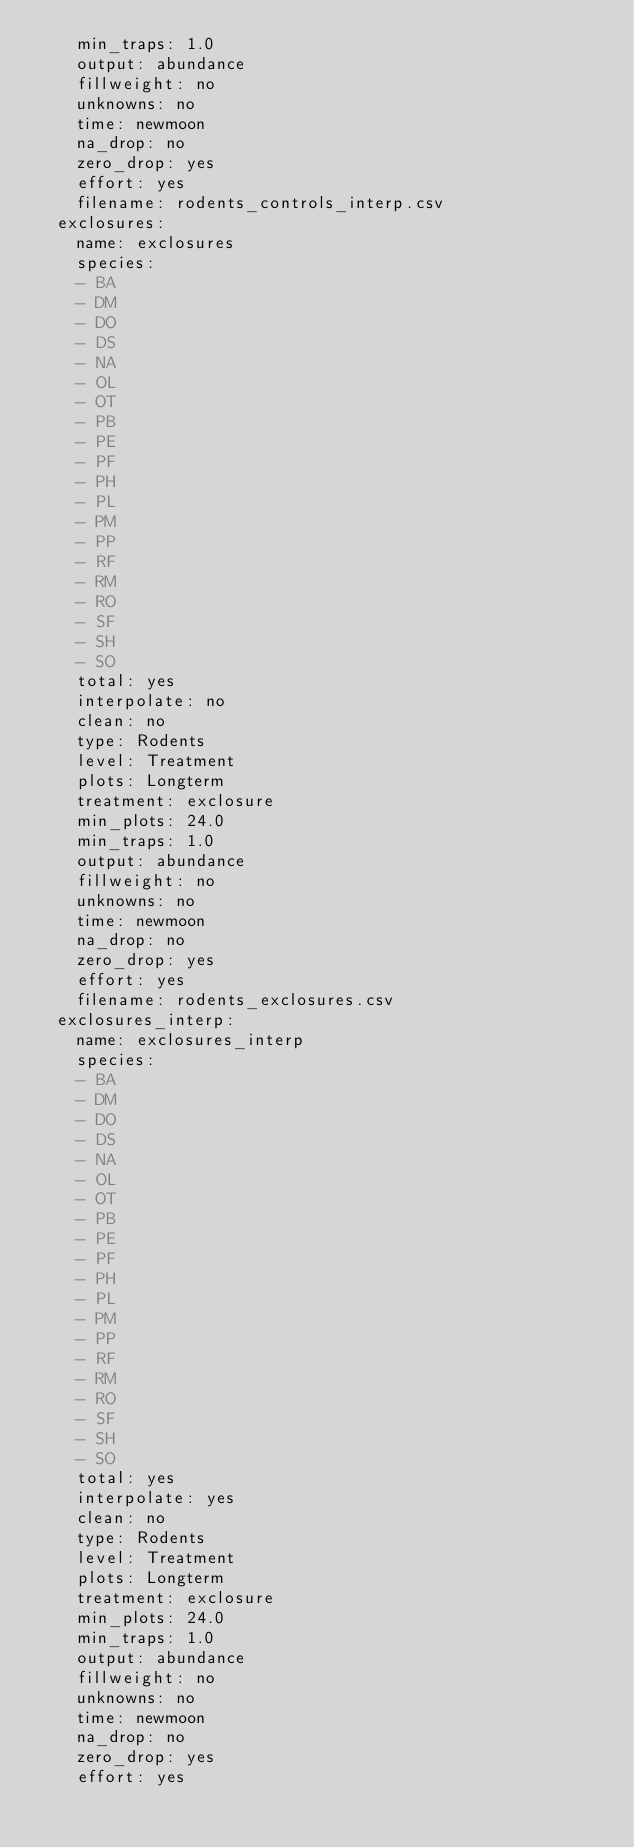Convert code to text. <code><loc_0><loc_0><loc_500><loc_500><_YAML_>    min_traps: 1.0
    output: abundance
    fillweight: no
    unknowns: no
    time: newmoon
    na_drop: no
    zero_drop: yes
    effort: yes
    filename: rodents_controls_interp.csv
  exclosures:
    name: exclosures
    species:
    - BA
    - DM
    - DO
    - DS
    - NA
    - OL
    - OT
    - PB
    - PE
    - PF
    - PH
    - PL
    - PM
    - PP
    - RF
    - RM
    - RO
    - SF
    - SH
    - SO
    total: yes
    interpolate: no
    clean: no
    type: Rodents
    level: Treatment
    plots: Longterm
    treatment: exclosure
    min_plots: 24.0
    min_traps: 1.0
    output: abundance
    fillweight: no
    unknowns: no
    time: newmoon
    na_drop: no
    zero_drop: yes
    effort: yes
    filename: rodents_exclosures.csv
  exclosures_interp:
    name: exclosures_interp
    species:
    - BA
    - DM
    - DO
    - DS
    - NA
    - OL
    - OT
    - PB
    - PE
    - PF
    - PH
    - PL
    - PM
    - PP
    - RF
    - RM
    - RO
    - SF
    - SH
    - SO
    total: yes
    interpolate: yes
    clean: no
    type: Rodents
    level: Treatment
    plots: Longterm
    treatment: exclosure
    min_plots: 24.0
    min_traps: 1.0
    output: abundance
    fillweight: no
    unknowns: no
    time: newmoon
    na_drop: no
    zero_drop: yes
    effort: yes</code> 